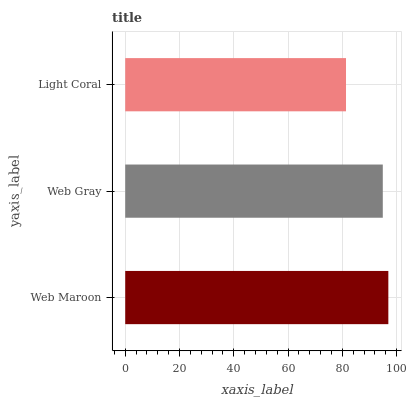Is Light Coral the minimum?
Answer yes or no. Yes. Is Web Maroon the maximum?
Answer yes or no. Yes. Is Web Gray the minimum?
Answer yes or no. No. Is Web Gray the maximum?
Answer yes or no. No. Is Web Maroon greater than Web Gray?
Answer yes or no. Yes. Is Web Gray less than Web Maroon?
Answer yes or no. Yes. Is Web Gray greater than Web Maroon?
Answer yes or no. No. Is Web Maroon less than Web Gray?
Answer yes or no. No. Is Web Gray the high median?
Answer yes or no. Yes. Is Web Gray the low median?
Answer yes or no. Yes. Is Light Coral the high median?
Answer yes or no. No. Is Light Coral the low median?
Answer yes or no. No. 